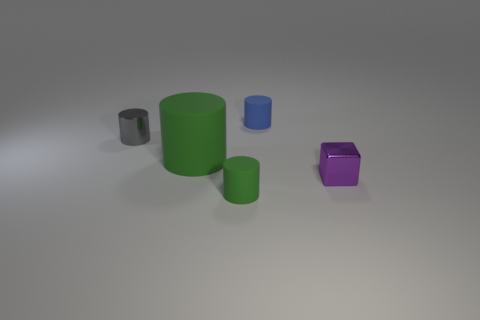Add 3 purple shiny things. How many objects exist? 8 Subtract all metallic cylinders. How many cylinders are left? 3 Subtract all gray cylinders. How many cylinders are left? 3 Subtract 2 cylinders. How many cylinders are left? 2 Subtract 0 yellow spheres. How many objects are left? 5 Subtract all cubes. How many objects are left? 4 Subtract all brown cylinders. Subtract all gray spheres. How many cylinders are left? 4 Subtract all red blocks. How many green cylinders are left? 2 Subtract all purple cylinders. Subtract all purple shiny blocks. How many objects are left? 4 Add 3 purple cubes. How many purple cubes are left? 4 